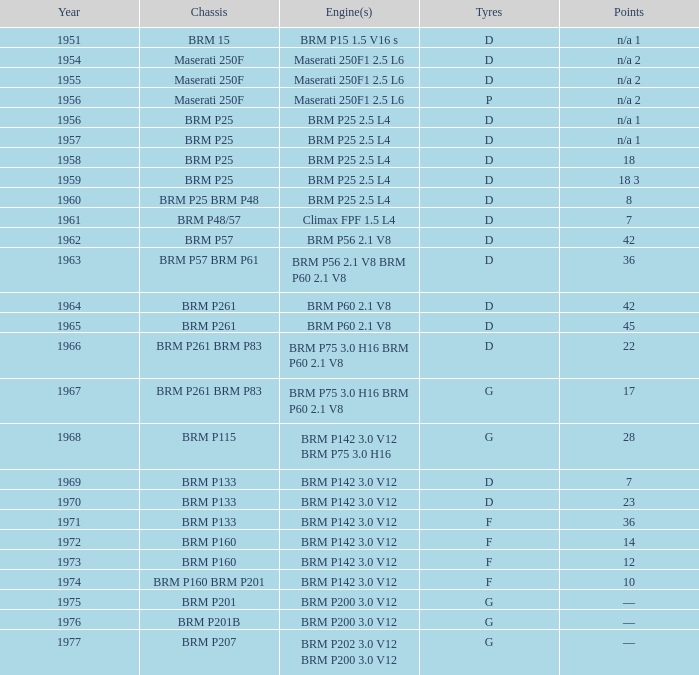Name the chassis for 1970 and tyres of d BRM P133. 